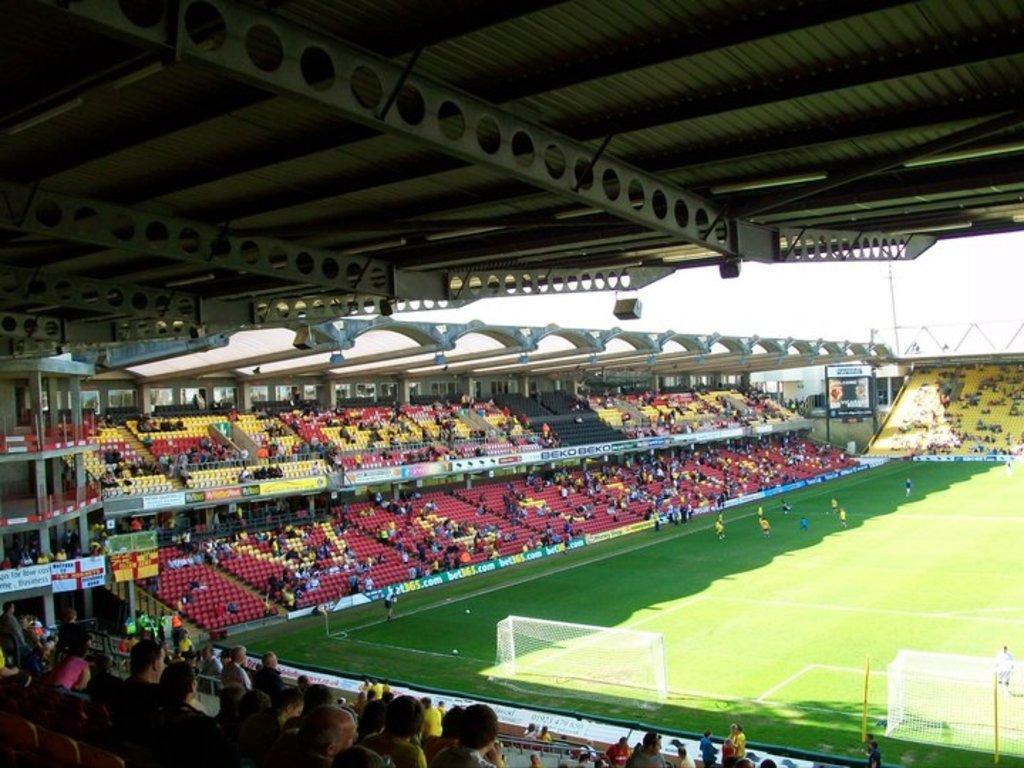Please provide a concise description of this image. In this image we can see the inside view of the stadium that includes the audience, ground, sports net and players. 